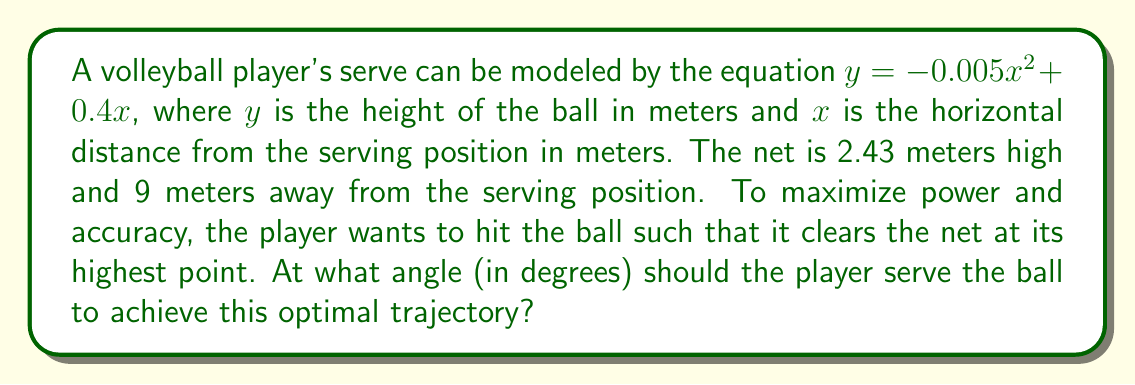Provide a solution to this math problem. To solve this problem, we'll follow these steps:

1) First, we need to find the highest point of the ball's trajectory. This occurs at the vertex of the parabola.

2) For a quadratic equation in the form $y = ax^2 + bx + c$, the x-coordinate of the vertex is given by $x = -\frac{b}{2a}$.

3) In our equation $y = -0.005x^2 + 0.4x$, $a = -0.005$ and $b = 0.4$. So:

   $x = -\frac{0.4}{2(-0.005)} = 40$ meters

4) This means the ball reaches its highest point 40 meters from the serving position.

5) We can find the height at this point by substituting $x = 40$ into our original equation:

   $y = -0.005(40)^2 + 0.4(40) = -8 + 16 = 8$ meters

6) Now we know the vertex of the parabola is at (40, 8).

7) To find the angle, we need to use trigonometry. We can create a right triangle from the serving position to the highest point.

8) The angle we're looking for is the angle between the ground and the line from the serving position to the highest point.

9) We can calculate this using the arctangent function:

   $\theta = \arctan(\frac{\text{opposite}}{\text{adjacent}}) = \arctan(\frac{8}{40})$

10) Calculate this:

    $\theta = \arctan(0.2) \approx 11.31$ degrees

Thus, the optimal angle for serving is approximately 11.31 degrees.

[asy]
import geometry;

size(200);

pair O=(0,0), A=(40,0), B=(40,8);
draw(O--A--B--O);

label("0", O, SW);
label("40 m", A, SE);
label("8 m", B, NE);
label("$\theta$", O, NE);

draw(arc(O,1,0,11.31), Arrow);
[/asy]
Answer: The optimal angle for serving is approximately 11.31 degrees. 